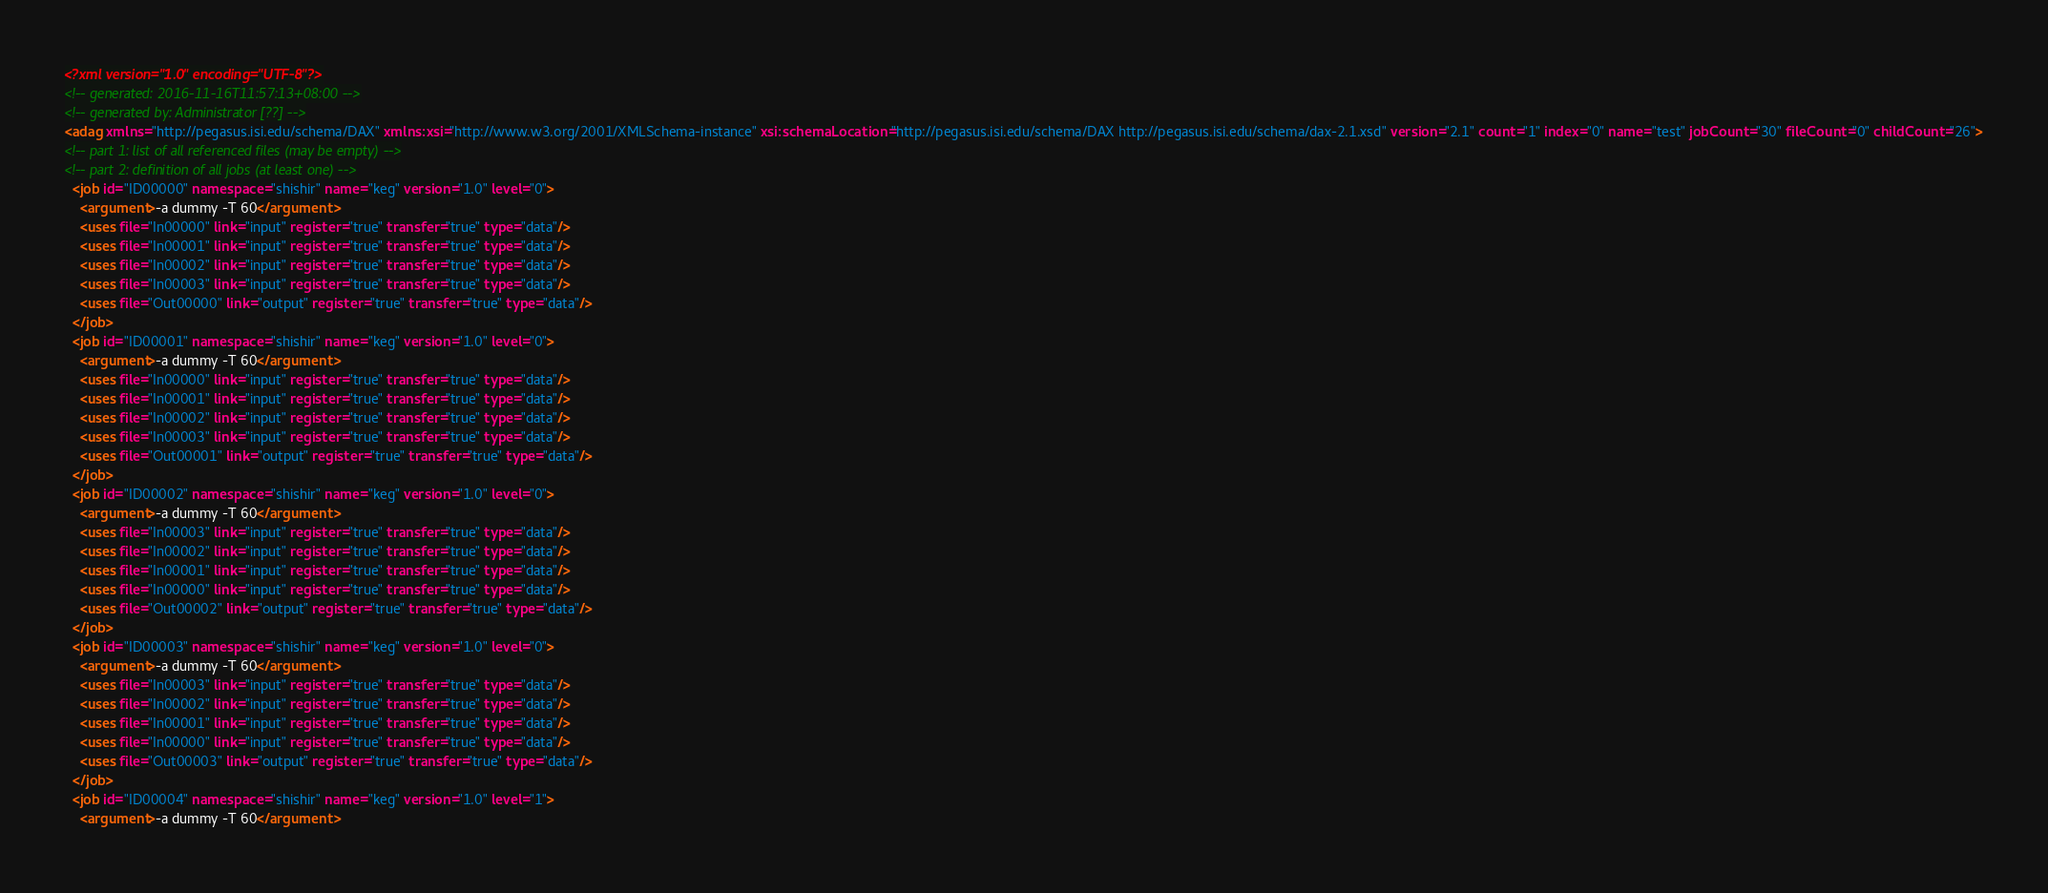<code> <loc_0><loc_0><loc_500><loc_500><_XML_><?xml version="1.0" encoding="UTF-8"?>
<!-- generated: 2016-11-16T11:57:13+08:00 -->
<!-- generated by: Administrator [??] -->
<adag xmlns="http://pegasus.isi.edu/schema/DAX" xmlns:xsi="http://www.w3.org/2001/XMLSchema-instance" xsi:schemaLocation="http://pegasus.isi.edu/schema/DAX http://pegasus.isi.edu/schema/dax-2.1.xsd" version="2.1" count="1" index="0" name="test" jobCount="30" fileCount="0" childCount="26">
<!-- part 1: list of all referenced files (may be empty) -->
<!-- part 2: definition of all jobs (at least one) -->
  <job id="ID00000" namespace="shishir" name="keg" version="1.0" level="0">
    <argument>-a dummy -T 60</argument>
    <uses file="In00000" link="input" register="true" transfer="true" type="data"/>
    <uses file="In00001" link="input" register="true" transfer="true" type="data"/>
    <uses file="In00002" link="input" register="true" transfer="true" type="data"/>
    <uses file="In00003" link="input" register="true" transfer="true" type="data"/>
    <uses file="Out00000" link="output" register="true" transfer="true" type="data"/>
  </job>
  <job id="ID00001" namespace="shishir" name="keg" version="1.0" level="0">
    <argument>-a dummy -T 60</argument>
    <uses file="In00000" link="input" register="true" transfer="true" type="data"/>
    <uses file="In00001" link="input" register="true" transfer="true" type="data"/>
    <uses file="In00002" link="input" register="true" transfer="true" type="data"/>
    <uses file="In00003" link="input" register="true" transfer="true" type="data"/>
    <uses file="Out00001" link="output" register="true" transfer="true" type="data"/>
  </job>
  <job id="ID00002" namespace="shishir" name="keg" version="1.0" level="0">
    <argument>-a dummy -T 60</argument>
    <uses file="In00003" link="input" register="true" transfer="true" type="data"/>
    <uses file="In00002" link="input" register="true" transfer="true" type="data"/>
    <uses file="In00001" link="input" register="true" transfer="true" type="data"/>
    <uses file="In00000" link="input" register="true" transfer="true" type="data"/>
    <uses file="Out00002" link="output" register="true" transfer="true" type="data"/>
  </job>
  <job id="ID00003" namespace="shishir" name="keg" version="1.0" level="0">
    <argument>-a dummy -T 60</argument>
    <uses file="In00003" link="input" register="true" transfer="true" type="data"/>
    <uses file="In00002" link="input" register="true" transfer="true" type="data"/>
    <uses file="In00001" link="input" register="true" transfer="true" type="data"/>
    <uses file="In00000" link="input" register="true" transfer="true" type="data"/>
    <uses file="Out00003" link="output" register="true" transfer="true" type="data"/>
  </job>
  <job id="ID00004" namespace="shishir" name="keg" version="1.0" level="1">
    <argument>-a dummy -T 60</argument></code> 